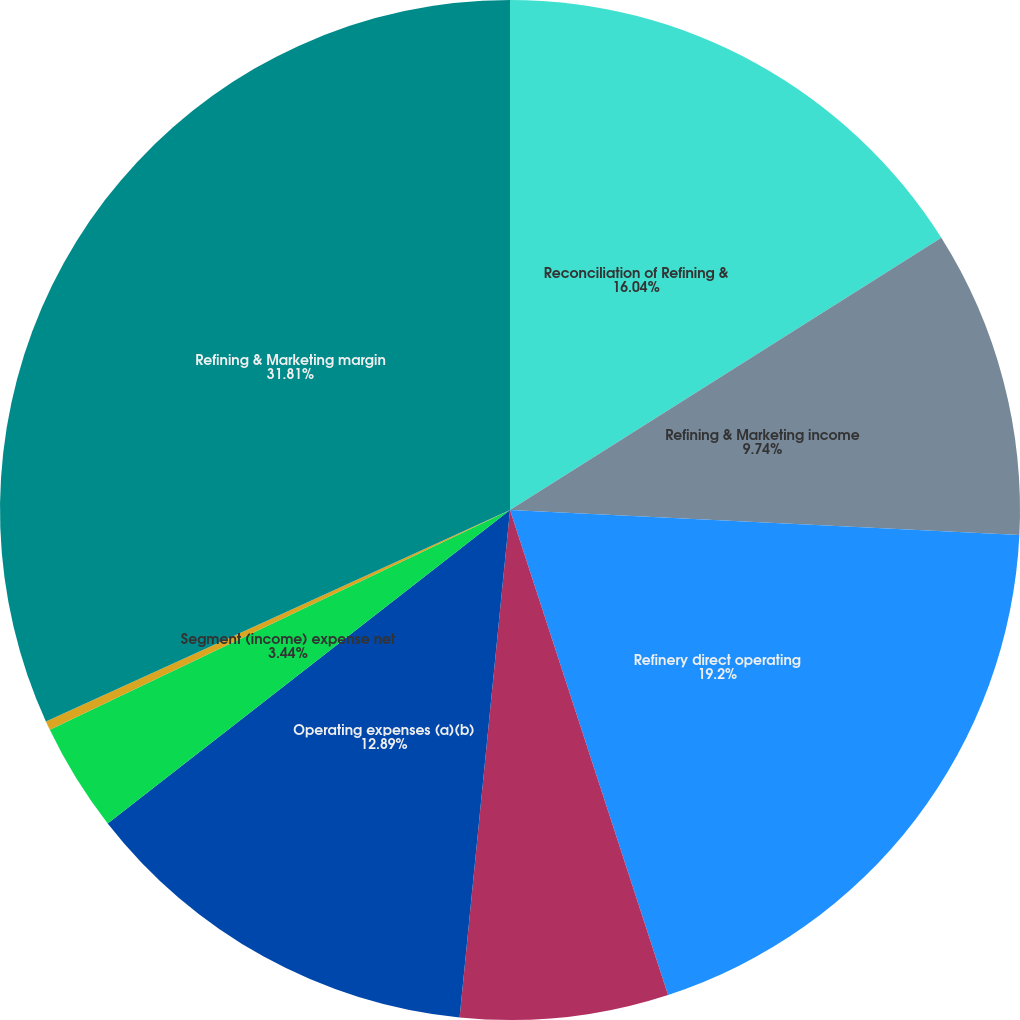Convert chart to OTSL. <chart><loc_0><loc_0><loc_500><loc_500><pie_chart><fcel>Reconciliation of Refining &<fcel>Refining & Marketing income<fcel>Refinery direct operating<fcel>Refinery depreciation and<fcel>Operating expenses (a)(b)<fcel>Segment (income) expense net<fcel>Depreciation and amortization<fcel>Refining & Marketing margin<nl><fcel>16.04%<fcel>9.74%<fcel>19.2%<fcel>6.59%<fcel>12.89%<fcel>3.44%<fcel>0.29%<fcel>31.8%<nl></chart> 